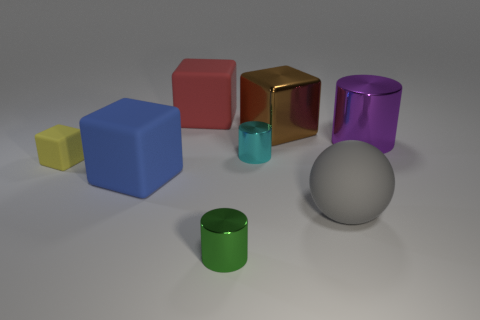Add 1 yellow matte objects. How many objects exist? 9 Subtract all cyan cubes. Subtract all cyan spheres. How many cubes are left? 4 Subtract all spheres. How many objects are left? 7 Subtract 0 red spheres. How many objects are left? 8 Subtract all large rubber balls. Subtract all large metallic cylinders. How many objects are left? 6 Add 5 big red matte objects. How many big red matte objects are left? 6 Add 8 gray spheres. How many gray spheres exist? 9 